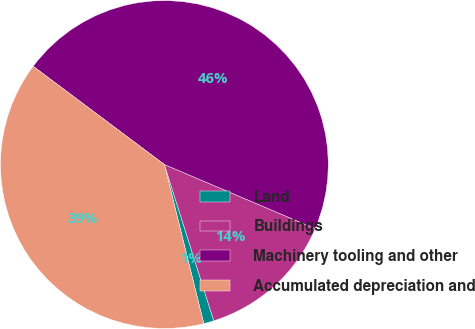Convert chart to OTSL. <chart><loc_0><loc_0><loc_500><loc_500><pie_chart><fcel>Land<fcel>Buildings<fcel>Machinery tooling and other<fcel>Accumulated depreciation and<nl><fcel>1.01%<fcel>13.73%<fcel>46.17%<fcel>39.09%<nl></chart> 